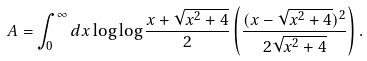<formula> <loc_0><loc_0><loc_500><loc_500>A = \int _ { 0 } ^ { \infty } d x \log \log { \frac { x + \sqrt { x ^ { 2 } + 4 } } { 2 } } \left ( \frac { ( x - \sqrt { x ^ { 2 } + 4 } ) ^ { 2 } } { 2 \sqrt { x ^ { 2 } + 4 } } \right ) .</formula> 